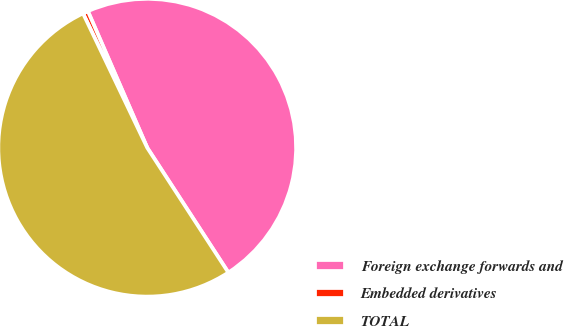Convert chart. <chart><loc_0><loc_0><loc_500><loc_500><pie_chart><fcel>Foreign exchange forwards and<fcel>Embedded derivatives<fcel>TOTAL<nl><fcel>47.35%<fcel>0.57%<fcel>52.08%<nl></chart> 